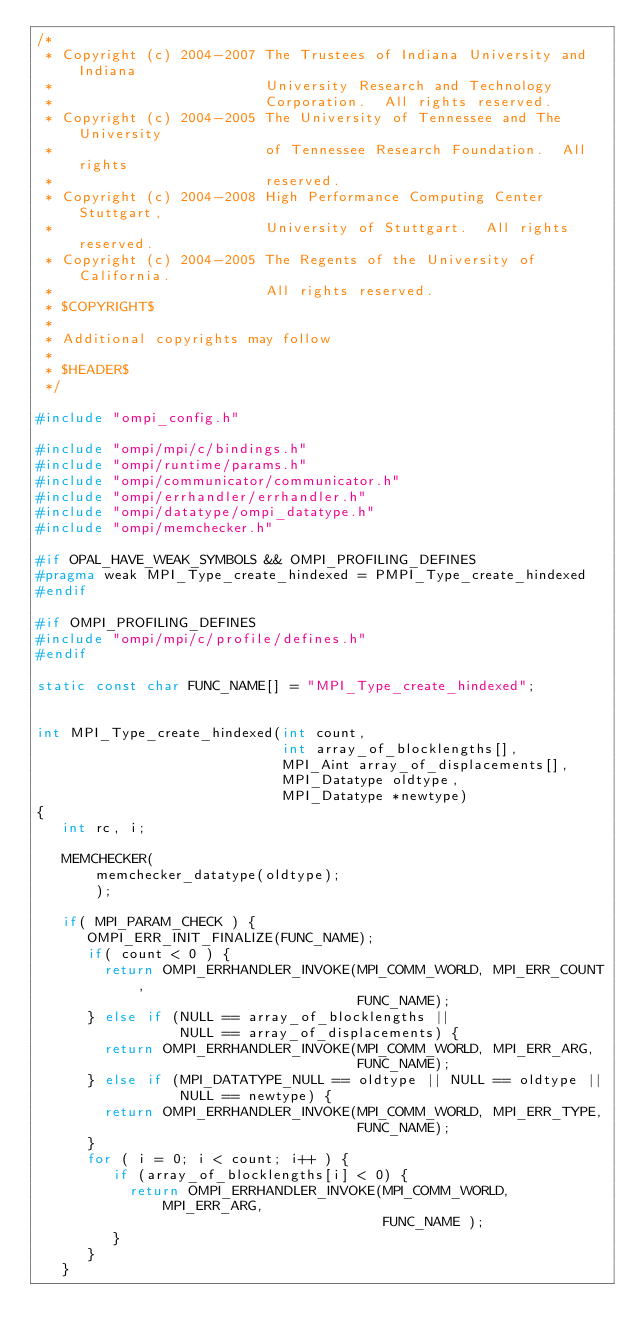<code> <loc_0><loc_0><loc_500><loc_500><_C_>/*
 * Copyright (c) 2004-2007 The Trustees of Indiana University and Indiana
 *                         University Research and Technology
 *                         Corporation.  All rights reserved.
 * Copyright (c) 2004-2005 The University of Tennessee and The University
 *                         of Tennessee Research Foundation.  All rights
 *                         reserved.
 * Copyright (c) 2004-2008 High Performance Computing Center Stuttgart, 
 *                         University of Stuttgart.  All rights reserved.
 * Copyright (c) 2004-2005 The Regents of the University of California.
 *                         All rights reserved.
 * $COPYRIGHT$
 * 
 * Additional copyrights may follow
 * 
 * $HEADER$
 */

#include "ompi_config.h"

#include "ompi/mpi/c/bindings.h"
#include "ompi/runtime/params.h"
#include "ompi/communicator/communicator.h"
#include "ompi/errhandler/errhandler.h"
#include "ompi/datatype/ompi_datatype.h"
#include "ompi/memchecker.h"

#if OPAL_HAVE_WEAK_SYMBOLS && OMPI_PROFILING_DEFINES
#pragma weak MPI_Type_create_hindexed = PMPI_Type_create_hindexed
#endif

#if OMPI_PROFILING_DEFINES
#include "ompi/mpi/c/profile/defines.h"
#endif

static const char FUNC_NAME[] = "MPI_Type_create_hindexed";


int MPI_Type_create_hindexed(int count,
                             int array_of_blocklengths[],
                             MPI_Aint array_of_displacements[],
                             MPI_Datatype oldtype,
                             MPI_Datatype *newtype)
{
   int rc, i;

   MEMCHECKER(
       memchecker_datatype(oldtype);
       );
   
   if( MPI_PARAM_CHECK ) {
      OMPI_ERR_INIT_FINALIZE(FUNC_NAME);
      if( count < 0 ) {
        return OMPI_ERRHANDLER_INVOKE(MPI_COMM_WORLD, MPI_ERR_COUNT, 
                                      FUNC_NAME);
      } else if (NULL == array_of_blocklengths ||
                 NULL == array_of_displacements) {
        return OMPI_ERRHANDLER_INVOKE(MPI_COMM_WORLD, MPI_ERR_ARG, 
                                      FUNC_NAME);
      } else if (MPI_DATATYPE_NULL == oldtype || NULL == oldtype ||
                 NULL == newtype) {
        return OMPI_ERRHANDLER_INVOKE(MPI_COMM_WORLD, MPI_ERR_TYPE,
                                      FUNC_NAME);
      }
      for ( i = 0; i < count; i++ ) {
         if (array_of_blocklengths[i] < 0) {
           return OMPI_ERRHANDLER_INVOKE(MPI_COMM_WORLD, MPI_ERR_ARG,
                                         FUNC_NAME );
         }
      }
   }
</code> 